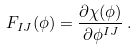<formula> <loc_0><loc_0><loc_500><loc_500>F _ { I J } ( \phi ) = \frac { \partial \chi ( \phi ) } { \partial \phi ^ { I J } } \, .</formula> 